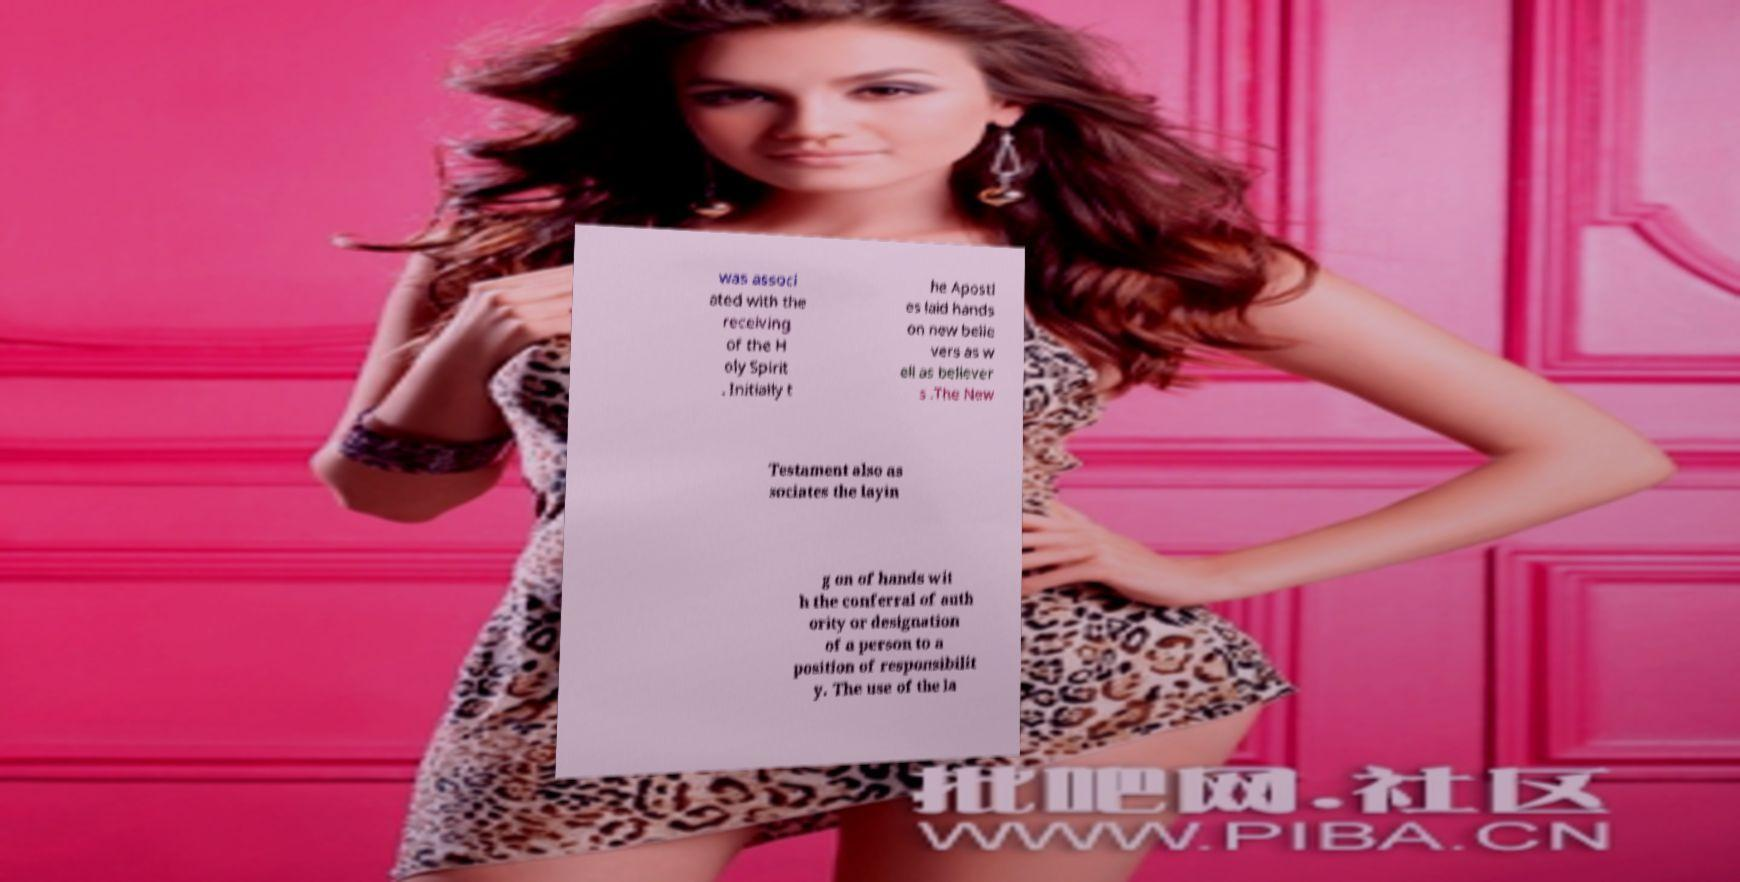Please read and relay the text visible in this image. What does it say? was associ ated with the receiving of the H oly Spirit . Initially t he Apostl es laid hands on new belie vers as w ell as believer s .The New Testament also as sociates the layin g on of hands wit h the conferral of auth ority or designation of a person to a position of responsibilit y. The use of the la 